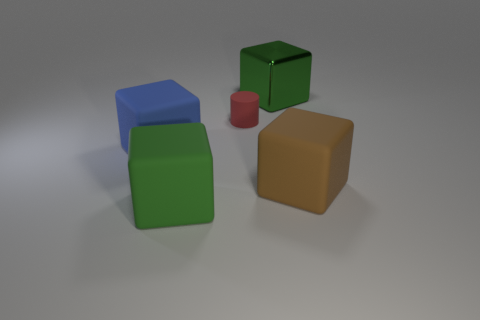The small red thing has what shape?
Provide a short and direct response. Cylinder. How many big cubes are in front of the big green rubber block?
Your answer should be compact. 0. What number of big gray balls have the same material as the large brown thing?
Provide a short and direct response. 0. Do the large green object in front of the large green shiny object and the tiny cylinder have the same material?
Give a very brief answer. Yes. Are there any purple rubber cylinders?
Your answer should be compact. No. There is a matte block that is left of the rubber cylinder and right of the big blue block; what size is it?
Offer a terse response. Large. Are there more blue blocks to the right of the large green metal cube than large green things in front of the blue thing?
Provide a short and direct response. No. There is a rubber thing that is the same color as the metallic cube; what size is it?
Provide a succinct answer. Large. The cylinder has what color?
Offer a very short reply. Red. There is a rubber thing that is on the left side of the tiny object and behind the green matte block; what is its color?
Give a very brief answer. Blue. 